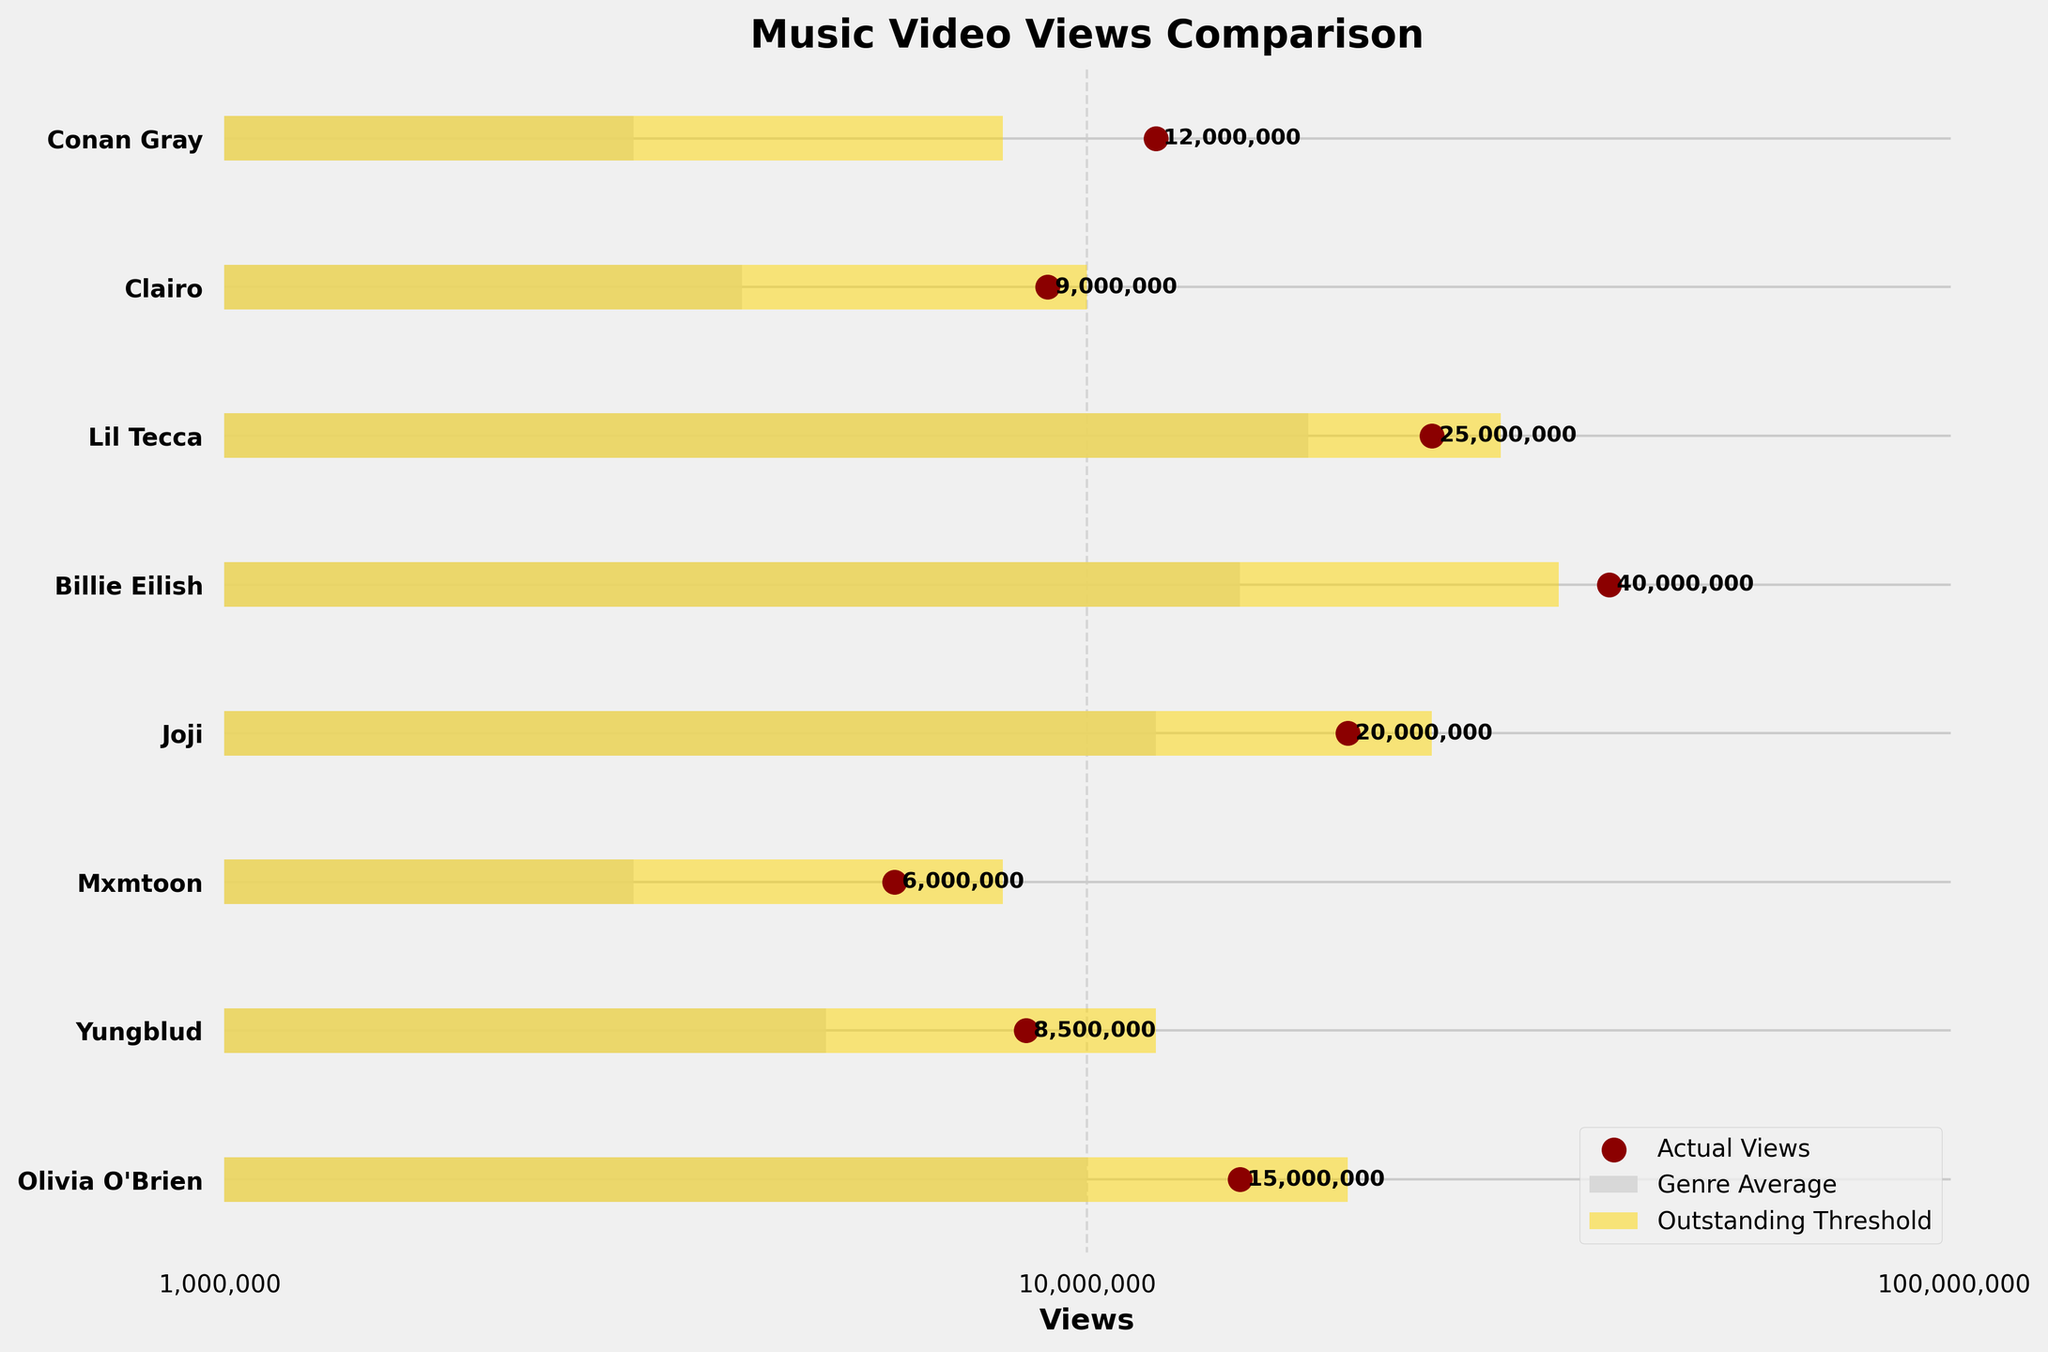What's the total number of artists displayed in the figure? To find the total number of artists, count the number of bars or data points listed on the y-axis. Each bar or data point corresponds to an artist.
Answer: 8 Which artist has music video views closest to their genre's average? We need to find which artist's view count is closest to their genre's average by visually checking the proximity of the scatter point (actual views) to the grey bar (genre average). Yungblud's views (8,500,000) are closest to the genre average (5,000,000) compared to others.
Answer: Yungblud Which artist exceeds their outstanding threshold? Look for scatter points (actual views) that are farther to the right than the gold bar (outstanding threshold). Billie Eilish's view count (40,000,000) exceeds her outstanding threshold (35,000,000).
Answer: Billie Eilish What's the difference between Conan Gray's actual views and the indie pop genre average? The actual views for Conan Gray is 12,000,000 and the genre average for Indie Pop is 3,000,000. Subtract the genre average from the actual views: 12,000,000 - 3,000,000 = 9,000,000.
Answer: 9,000,000 What's the median number of actual views across all artists? To find the median, list the actual views in ascending order: 6,000,000, 8,500,000, 9,000,000, 12,000,000, 15,000,000, 20,000,000, 25,000,000, 40,000,000. There are 8 values, so the median is the average of the 4th and 5th values: (12,000,000 + 15,000,000)/2 = 13,500,000.
Answer: 13,500,000 Which artist has the highest deviation above their genre average? To find the highest deviation, subtract each genre average from the actual views for each artist, then identify the largest result. For Billie Eilish, it's 40,000,000 - 15,000,000 = 25,000,000 which is higher than the others' deviations.
Answer: Billie Eilish Are there any artists whose views are below their genre average? Look for scatter points (actual views) positioned to the left of the grey bar (genre average). There are no points like this; all actual views are above their genre averages.
Answer: No Which genre average is the highest? Compare the length of the grey bars (genre averages) and identify the longest one. The highest genre average is for Billie Eilish in the Electropop genre with 15,000,000 views.
Answer: Electropop Between Yungblud and Joji, who has fewer views and by how much? Yungblud's views are 8,500,000 and Joji's are 20,000,000. Subtract Yungblud's views from Joji's: 20,000,000 - 8,500,000 = 11,500,000.
Answer: Yungblud, 11,500,000 less 